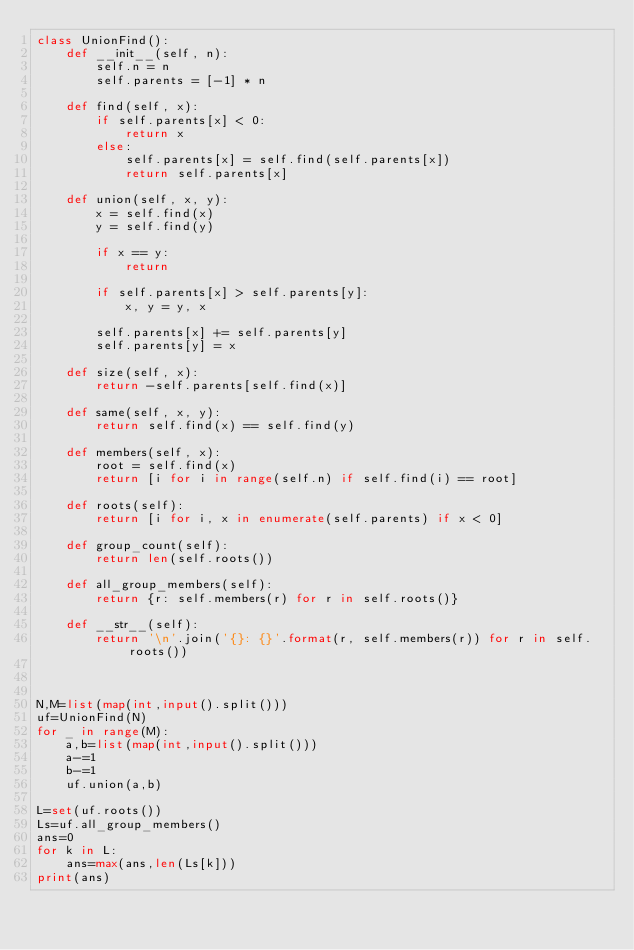<code> <loc_0><loc_0><loc_500><loc_500><_Python_>class UnionFind():
    def __init__(self, n):
        self.n = n
        self.parents = [-1] * n

    def find(self, x):
        if self.parents[x] < 0:
            return x
        else:
            self.parents[x] = self.find(self.parents[x])
            return self.parents[x]

    def union(self, x, y):
        x = self.find(x)
        y = self.find(y)

        if x == y:
            return

        if self.parents[x] > self.parents[y]:
            x, y = y, x

        self.parents[x] += self.parents[y]
        self.parents[y] = x

    def size(self, x):
        return -self.parents[self.find(x)]

    def same(self, x, y):
        return self.find(x) == self.find(y)

    def members(self, x):
        root = self.find(x)
        return [i for i in range(self.n) if self.find(i) == root]

    def roots(self):
        return [i for i, x in enumerate(self.parents) if x < 0]

    def group_count(self):
        return len(self.roots())

    def all_group_members(self):
        return {r: self.members(r) for r in self.roots()}

    def __str__(self):
        return '\n'.join('{}: {}'.format(r, self.members(r)) for r in self.roots())



N,M=list(map(int,input().split()))
uf=UnionFind(N)
for _ in range(M):
    a,b=list(map(int,input().split()))
    a-=1
    b-=1
    uf.union(a,b)

L=set(uf.roots())
Ls=uf.all_group_members()
ans=0
for k in L:
    ans=max(ans,len(Ls[k]))
print(ans)</code> 